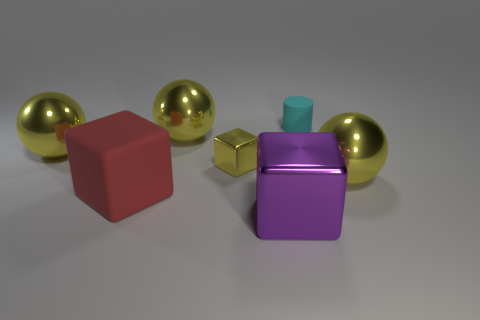Is there anything else that has the same size as the cyan object?
Offer a terse response. Yes. Do the large yellow object that is in front of the small cube and the tiny metallic object have the same shape?
Make the answer very short. No. Is the number of yellow blocks right of the cylinder greater than the number of red matte things?
Make the answer very short. No. The large sphere that is to the right of the cyan cylinder that is behind the tiny cube is what color?
Offer a very short reply. Yellow. What number of tiny brown rubber objects are there?
Offer a very short reply. 0. How many yellow balls are on the left side of the big purple metallic thing and right of the cyan object?
Offer a terse response. 0. Are there any other things that have the same shape as the big matte object?
Offer a terse response. Yes. Does the large matte thing have the same color as the cube that is behind the red cube?
Offer a terse response. No. There is a large thing that is in front of the red block; what shape is it?
Your answer should be very brief. Cube. How many other objects are there of the same material as the large red cube?
Your answer should be compact. 1. 